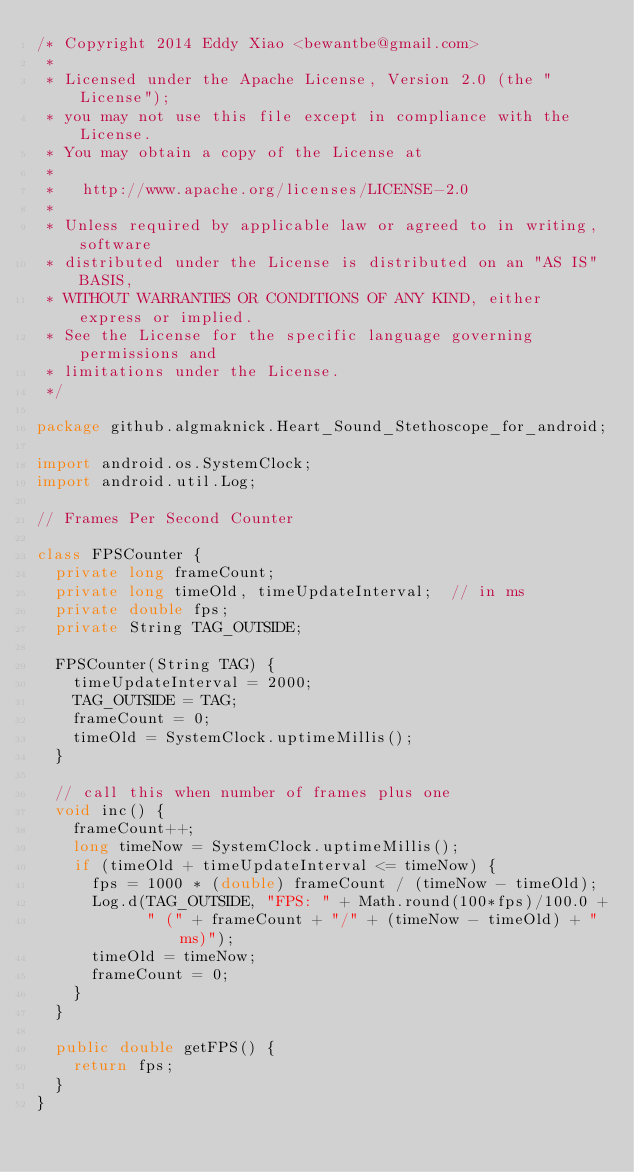<code> <loc_0><loc_0><loc_500><loc_500><_Java_>/* Copyright 2014 Eddy Xiao <bewantbe@gmail.com>
 *
 * Licensed under the Apache License, Version 2.0 (the "License");
 * you may not use this file except in compliance with the License.
 * You may obtain a copy of the License at
 *
 *   http://www.apache.org/licenses/LICENSE-2.0
 *
 * Unless required by applicable law or agreed to in writing, software
 * distributed under the License is distributed on an "AS IS" BASIS,
 * WITHOUT WARRANTIES OR CONDITIONS OF ANY KIND, either express or implied.
 * See the License for the specific language governing permissions and
 * limitations under the License.
 */

package github.algmaknick.Heart_Sound_Stethoscope_for_android;

import android.os.SystemClock;
import android.util.Log;

// Frames Per Second Counter

class FPSCounter {
  private long frameCount;
  private long timeOld, timeUpdateInterval;  // in ms
  private double fps;
  private String TAG_OUTSIDE;
  
  FPSCounter(String TAG) {
    timeUpdateInterval = 2000;
    TAG_OUTSIDE = TAG;
    frameCount = 0;
    timeOld = SystemClock.uptimeMillis();
  }
  
  // call this when number of frames plus one
  void inc() {
    frameCount++;
    long timeNow = SystemClock.uptimeMillis();
    if (timeOld + timeUpdateInterval <= timeNow) {
      fps = 1000 * (double) frameCount / (timeNow - timeOld);
      Log.d(TAG_OUTSIDE, "FPS: " + Math.round(100*fps)/100.0 +
            " (" + frameCount + "/" + (timeNow - timeOld) + "ms)");
      timeOld = timeNow;
      frameCount = 0;
    }
  }

  public double getFPS() {
    return fps;
  }
}
</code> 